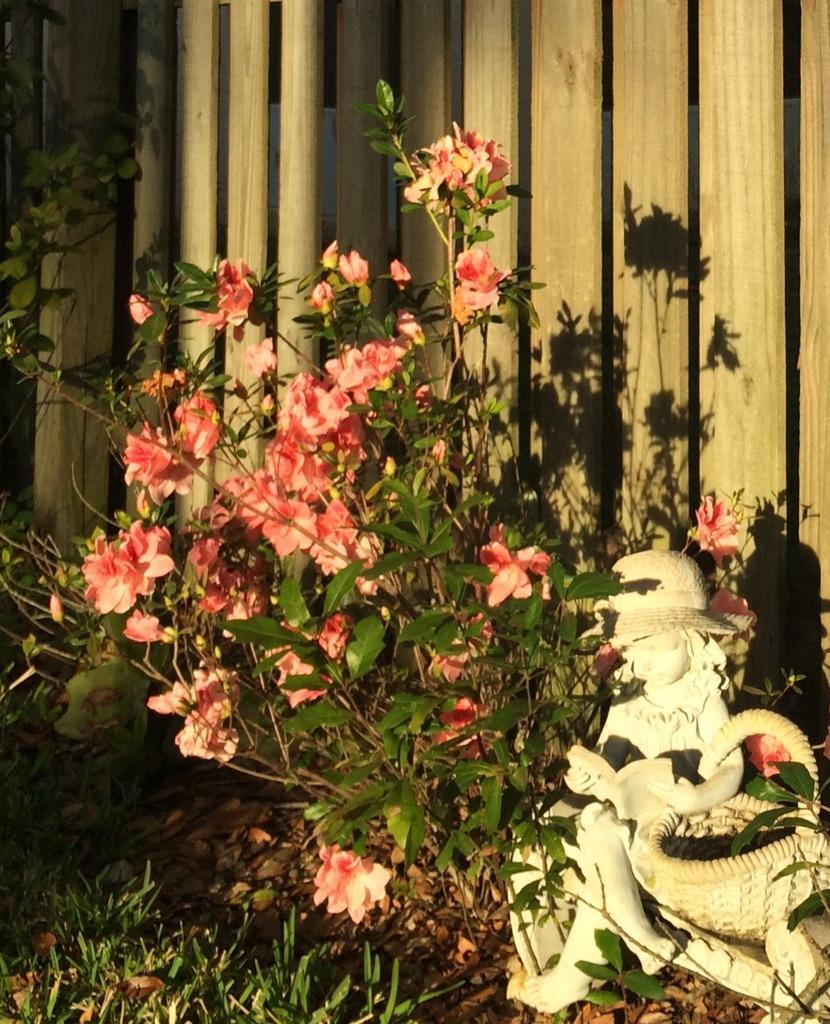Please provide a concise description of this image. In this image we can see few flowers and leaves of a plant, beside the plant there is a statue, behind the plant there is a wooden wall. 